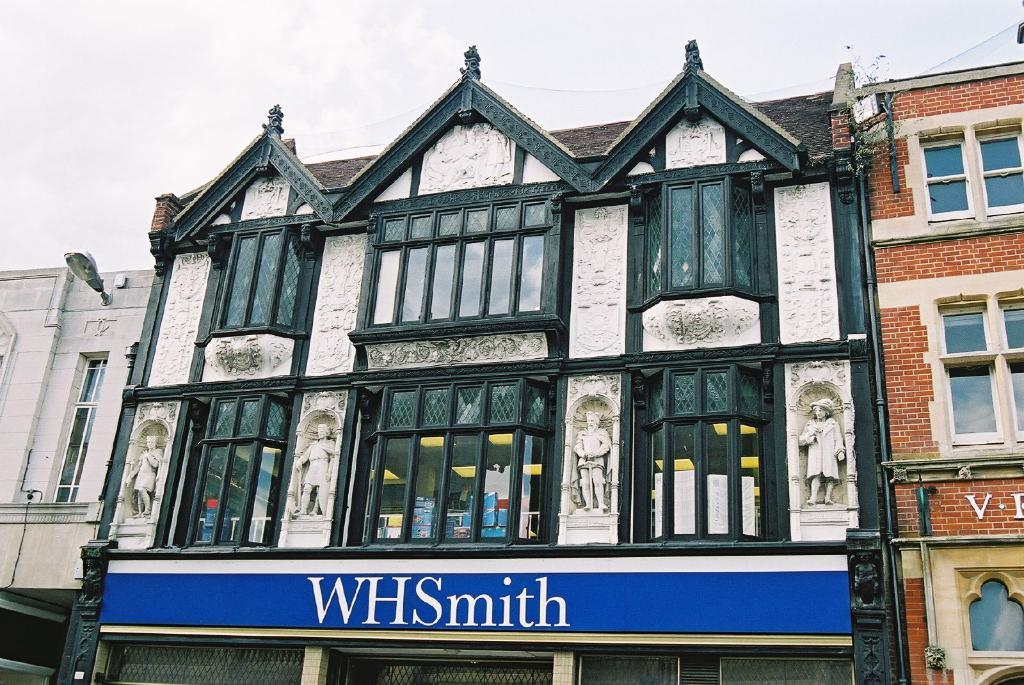What type of structure is visible in the image? There is a building in the image. What feature can be observed on the building? The building has windows and glass walls. Are there any decorative elements on the building? Yes, there are statues on the walls of the building. What can be seen at the top of the image? The sky is visible at the top of the image. How can the name of the building be identified? There is a name board in the image. Can you compare the road in front of the building to the road in another image? There is no road visible in the image, so it cannot be compared to a road in another image. 